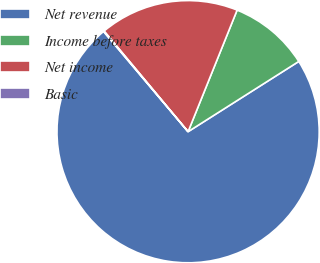<chart> <loc_0><loc_0><loc_500><loc_500><pie_chart><fcel>Net revenue<fcel>Income before taxes<fcel>Net income<fcel>Basic<nl><fcel>72.85%<fcel>9.9%<fcel>17.17%<fcel>0.08%<nl></chart> 